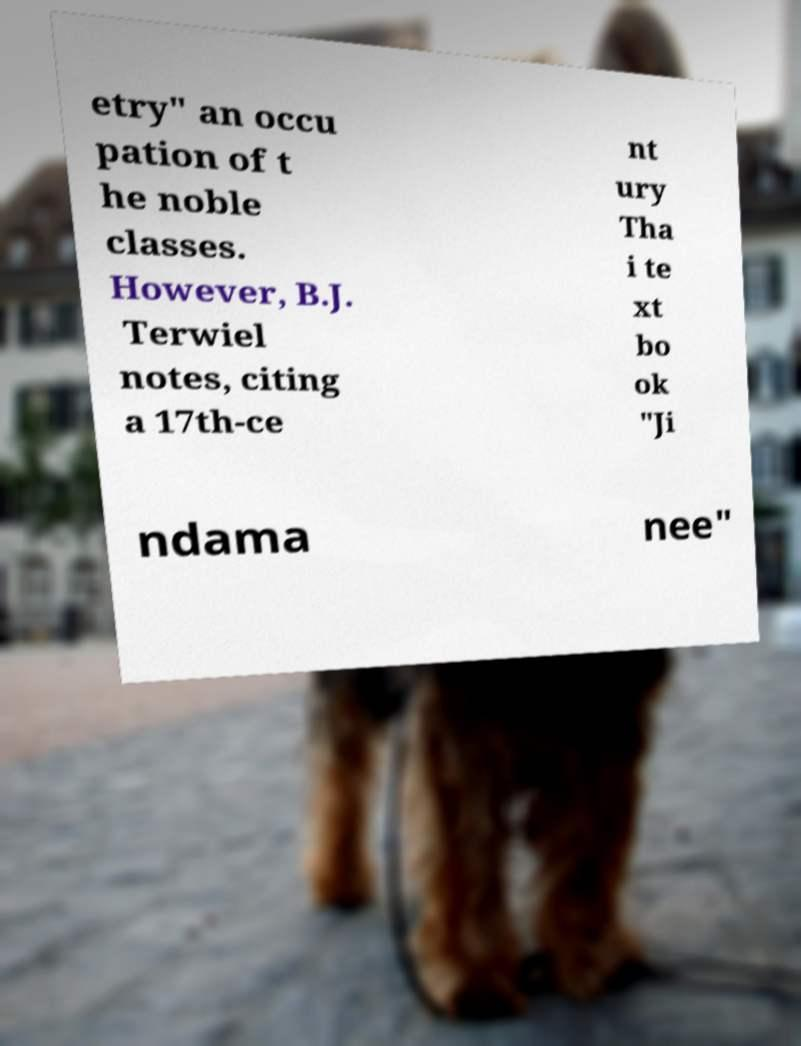Could you assist in decoding the text presented in this image and type it out clearly? etry" an occu pation of t he noble classes. However, B.J. Terwiel notes, citing a 17th-ce nt ury Tha i te xt bo ok "Ji ndama nee" 